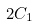Convert formula to latex. <formula><loc_0><loc_0><loc_500><loc_500>2 C _ { 1 }</formula> 